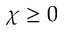<formula> <loc_0><loc_0><loc_500><loc_500>\chi \geq 0</formula> 